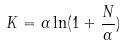Convert formula to latex. <formula><loc_0><loc_0><loc_500><loc_500>K = \alpha \ln ( 1 + \frac { N } { \alpha } )</formula> 